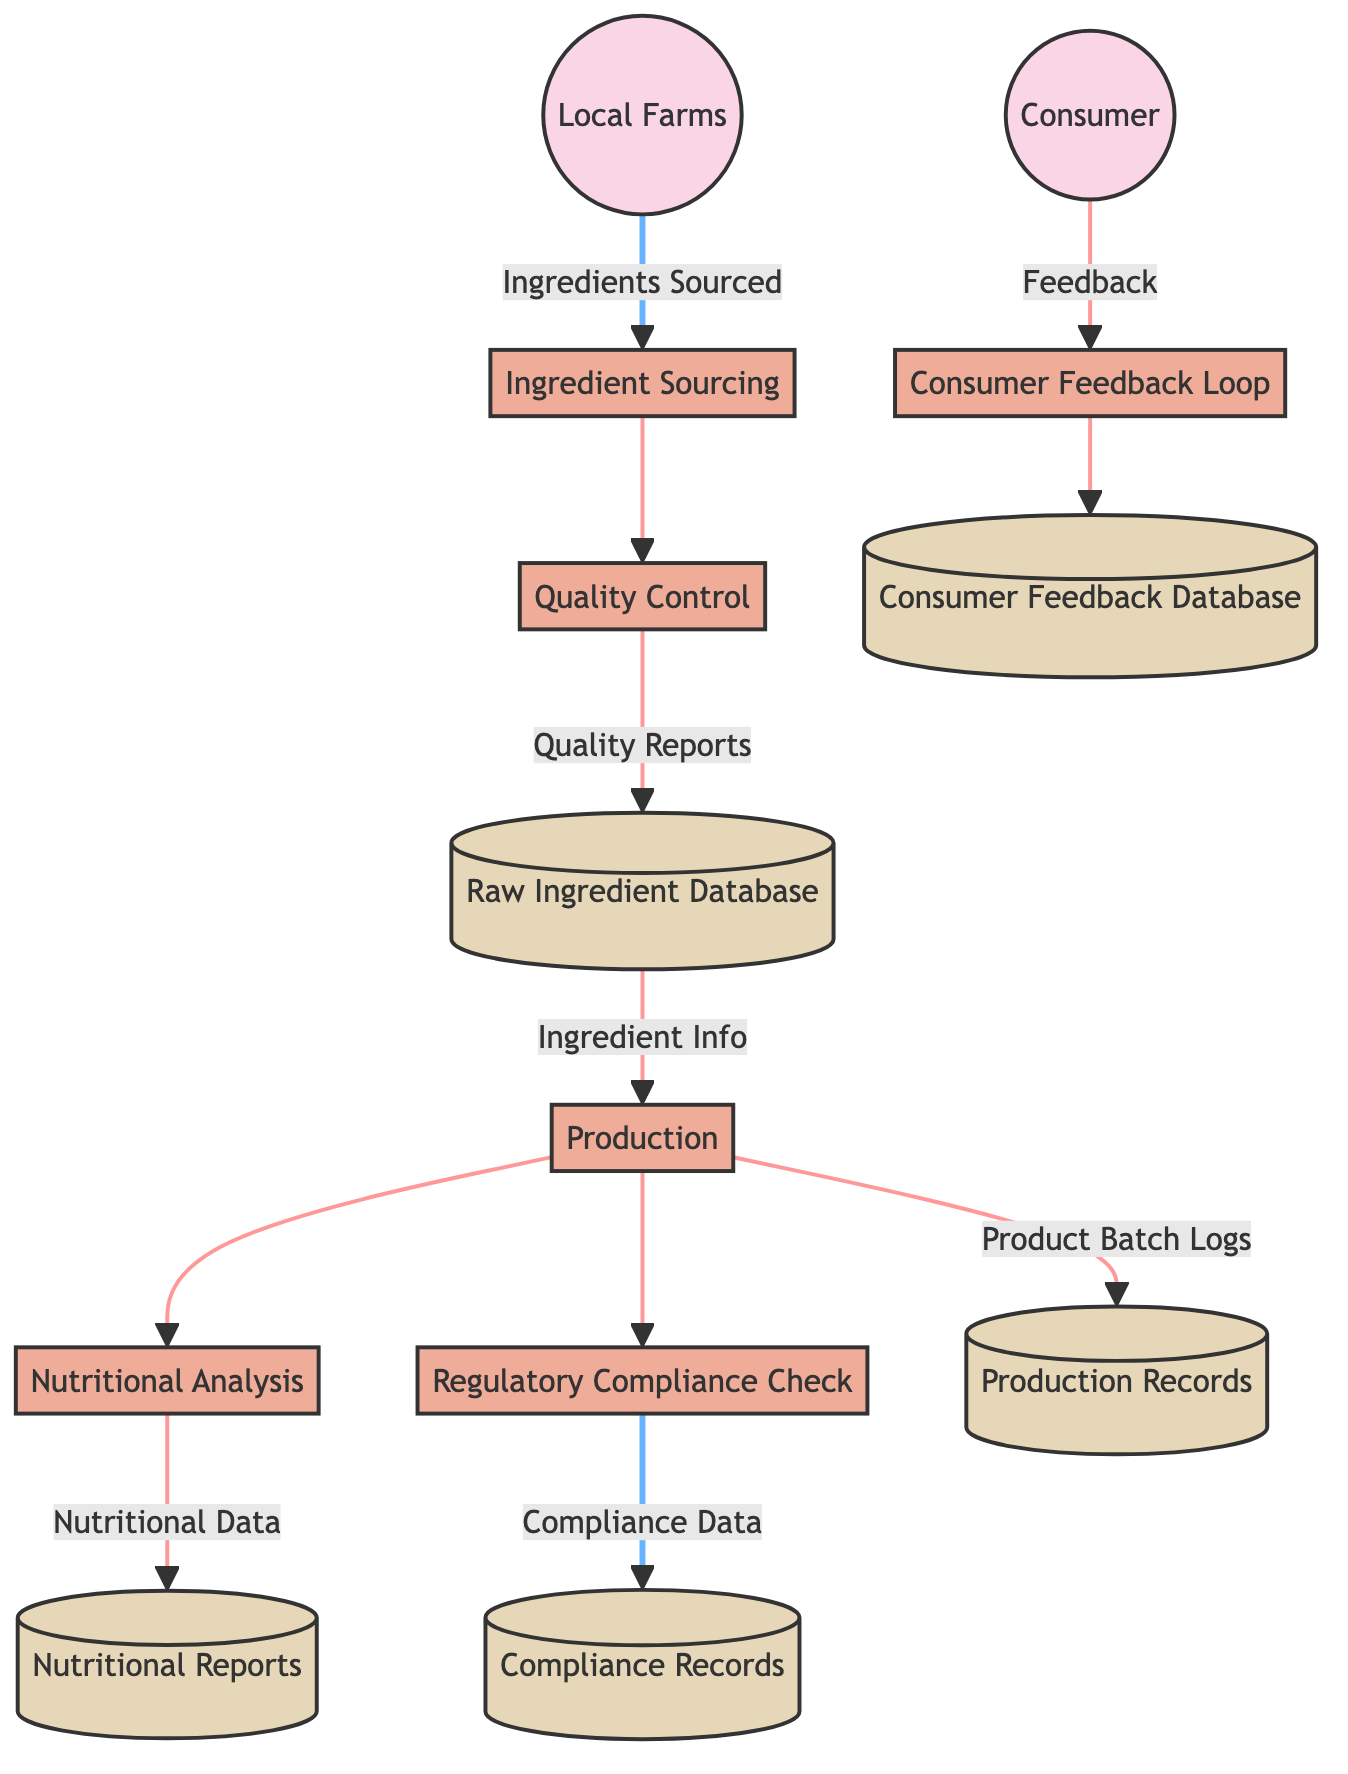How many external entities are present in the diagram? The diagram contains two external entities: Consumer and Local Farms. Counting these, we find that there are a total of two external entities listed.
Answer: 2 What does the Quality Control process produce? The Quality Control process produces Quality Reports, which flow into the Raw Ingredient Database. This information is explicitly indicated in the data flow connections shown in the diagram.
Answer: Quality Reports Which process is responsible for verifying nutritional content? Nutritional Analysis is the designated process responsible for verifying the nutritional content of the vegetarian products. This is directly stated in the diagram.
Answer: Nutritional Analysis From which entity do ingredients flow into the Ingredient Sourcing process? Ingredients flow into the Ingredient Sourcing process from Local Farms, as depicted by the directional flow indicated in the diagram.
Answer: Local Farms What data store contains information about compliance with regulations? The Compliance Records data store contains documentation of regulatory compliance checks, which is clearly specified in the diagram.
Answer: Compliance Records What action connects the Consumer to the Consumer Feedback Loop? The action connecting the Consumer to the Consumer Feedback Loop is the flow of Feedback. This interaction is outlined in the diagram, showing the Consumer providing feedback.
Answer: Feedback Describe the relationship between the Production process and the Regulatory Compliance Check process. The Production process feeds into the Regulatory Compliance Check process, indicating that after production, products are checked for compliance against standards. This flow demonstrates the sequence from production to compliance verification.
Answer: Production feeds into Regulatory Compliance Check Which data store receives nutritional data? Nutritional Reports receive the flow of Nutritional Data from the Nutritional Analysis process, establishing their relationship as indicated in the process-to-data store connection in the diagram.
Answer: Nutritional Reports 